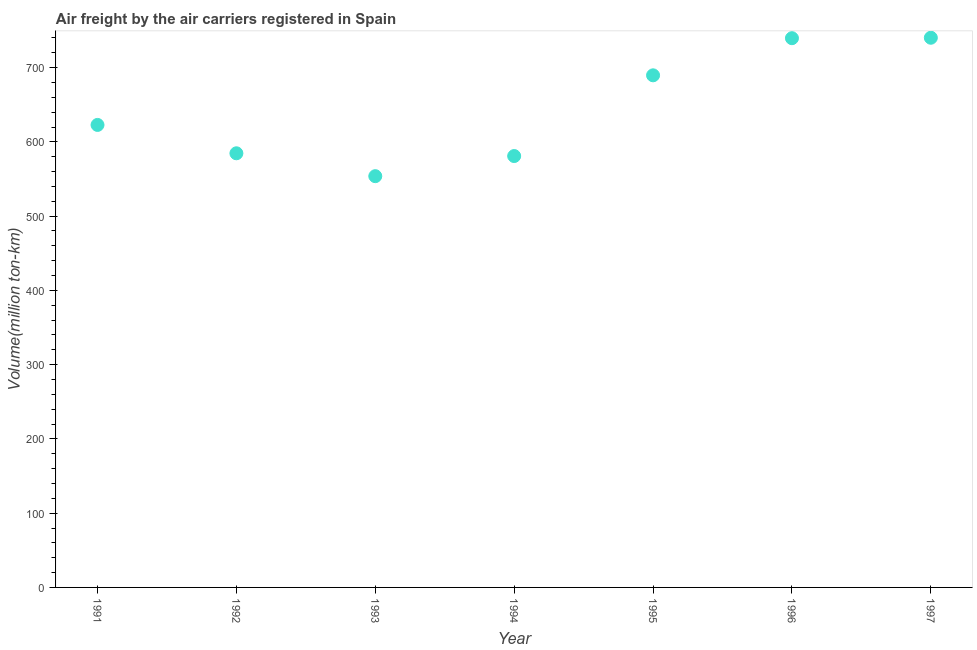What is the air freight in 1992?
Your answer should be compact. 584.6. Across all years, what is the maximum air freight?
Your response must be concise. 740.2. Across all years, what is the minimum air freight?
Your response must be concise. 553.8. What is the sum of the air freight?
Provide a short and direct response. 4511.5. What is the difference between the air freight in 1992 and 1997?
Make the answer very short. -155.6. What is the average air freight per year?
Your response must be concise. 644.5. What is the median air freight?
Ensure brevity in your answer.  622.8. Do a majority of the years between 1995 and 1992 (inclusive) have air freight greater than 460 million ton-km?
Provide a succinct answer. Yes. What is the ratio of the air freight in 1991 to that in 1997?
Offer a terse response. 0.84. Is the air freight in 1992 less than that in 1996?
Provide a succinct answer. Yes. Is the difference between the air freight in 1992 and 1995 greater than the difference between any two years?
Provide a short and direct response. No. What is the difference between the highest and the second highest air freight?
Give a very brief answer. 0.6. What is the difference between the highest and the lowest air freight?
Your answer should be very brief. 186.4. How many years are there in the graph?
Keep it short and to the point. 7. Does the graph contain any zero values?
Your answer should be compact. No. What is the title of the graph?
Your answer should be compact. Air freight by the air carriers registered in Spain. What is the label or title of the X-axis?
Your answer should be compact. Year. What is the label or title of the Y-axis?
Your answer should be compact. Volume(million ton-km). What is the Volume(million ton-km) in 1991?
Your response must be concise. 622.8. What is the Volume(million ton-km) in 1992?
Provide a short and direct response. 584.6. What is the Volume(million ton-km) in 1993?
Your answer should be compact. 553.8. What is the Volume(million ton-km) in 1994?
Provide a short and direct response. 580.9. What is the Volume(million ton-km) in 1995?
Keep it short and to the point. 689.6. What is the Volume(million ton-km) in 1996?
Your response must be concise. 739.6. What is the Volume(million ton-km) in 1997?
Offer a terse response. 740.2. What is the difference between the Volume(million ton-km) in 1991 and 1992?
Offer a very short reply. 38.2. What is the difference between the Volume(million ton-km) in 1991 and 1994?
Your answer should be compact. 41.9. What is the difference between the Volume(million ton-km) in 1991 and 1995?
Give a very brief answer. -66.8. What is the difference between the Volume(million ton-km) in 1991 and 1996?
Your answer should be compact. -116.8. What is the difference between the Volume(million ton-km) in 1991 and 1997?
Your response must be concise. -117.4. What is the difference between the Volume(million ton-km) in 1992 and 1993?
Offer a terse response. 30.8. What is the difference between the Volume(million ton-km) in 1992 and 1994?
Your answer should be very brief. 3.7. What is the difference between the Volume(million ton-km) in 1992 and 1995?
Give a very brief answer. -105. What is the difference between the Volume(million ton-km) in 1992 and 1996?
Make the answer very short. -155. What is the difference between the Volume(million ton-km) in 1992 and 1997?
Give a very brief answer. -155.6. What is the difference between the Volume(million ton-km) in 1993 and 1994?
Your response must be concise. -27.1. What is the difference between the Volume(million ton-km) in 1993 and 1995?
Your response must be concise. -135.8. What is the difference between the Volume(million ton-km) in 1993 and 1996?
Ensure brevity in your answer.  -185.8. What is the difference between the Volume(million ton-km) in 1993 and 1997?
Your response must be concise. -186.4. What is the difference between the Volume(million ton-km) in 1994 and 1995?
Your answer should be compact. -108.7. What is the difference between the Volume(million ton-km) in 1994 and 1996?
Provide a short and direct response. -158.7. What is the difference between the Volume(million ton-km) in 1994 and 1997?
Offer a terse response. -159.3. What is the difference between the Volume(million ton-km) in 1995 and 1997?
Your answer should be compact. -50.6. What is the difference between the Volume(million ton-km) in 1996 and 1997?
Give a very brief answer. -0.6. What is the ratio of the Volume(million ton-km) in 1991 to that in 1992?
Give a very brief answer. 1.06. What is the ratio of the Volume(million ton-km) in 1991 to that in 1994?
Ensure brevity in your answer.  1.07. What is the ratio of the Volume(million ton-km) in 1991 to that in 1995?
Offer a very short reply. 0.9. What is the ratio of the Volume(million ton-km) in 1991 to that in 1996?
Offer a terse response. 0.84. What is the ratio of the Volume(million ton-km) in 1991 to that in 1997?
Provide a succinct answer. 0.84. What is the ratio of the Volume(million ton-km) in 1992 to that in 1993?
Provide a short and direct response. 1.06. What is the ratio of the Volume(million ton-km) in 1992 to that in 1995?
Offer a very short reply. 0.85. What is the ratio of the Volume(million ton-km) in 1992 to that in 1996?
Make the answer very short. 0.79. What is the ratio of the Volume(million ton-km) in 1992 to that in 1997?
Provide a short and direct response. 0.79. What is the ratio of the Volume(million ton-km) in 1993 to that in 1994?
Offer a terse response. 0.95. What is the ratio of the Volume(million ton-km) in 1993 to that in 1995?
Your answer should be compact. 0.8. What is the ratio of the Volume(million ton-km) in 1993 to that in 1996?
Provide a short and direct response. 0.75. What is the ratio of the Volume(million ton-km) in 1993 to that in 1997?
Your answer should be very brief. 0.75. What is the ratio of the Volume(million ton-km) in 1994 to that in 1995?
Ensure brevity in your answer.  0.84. What is the ratio of the Volume(million ton-km) in 1994 to that in 1996?
Give a very brief answer. 0.79. What is the ratio of the Volume(million ton-km) in 1994 to that in 1997?
Provide a short and direct response. 0.79. What is the ratio of the Volume(million ton-km) in 1995 to that in 1996?
Your answer should be compact. 0.93. What is the ratio of the Volume(million ton-km) in 1995 to that in 1997?
Give a very brief answer. 0.93. What is the ratio of the Volume(million ton-km) in 1996 to that in 1997?
Make the answer very short. 1. 